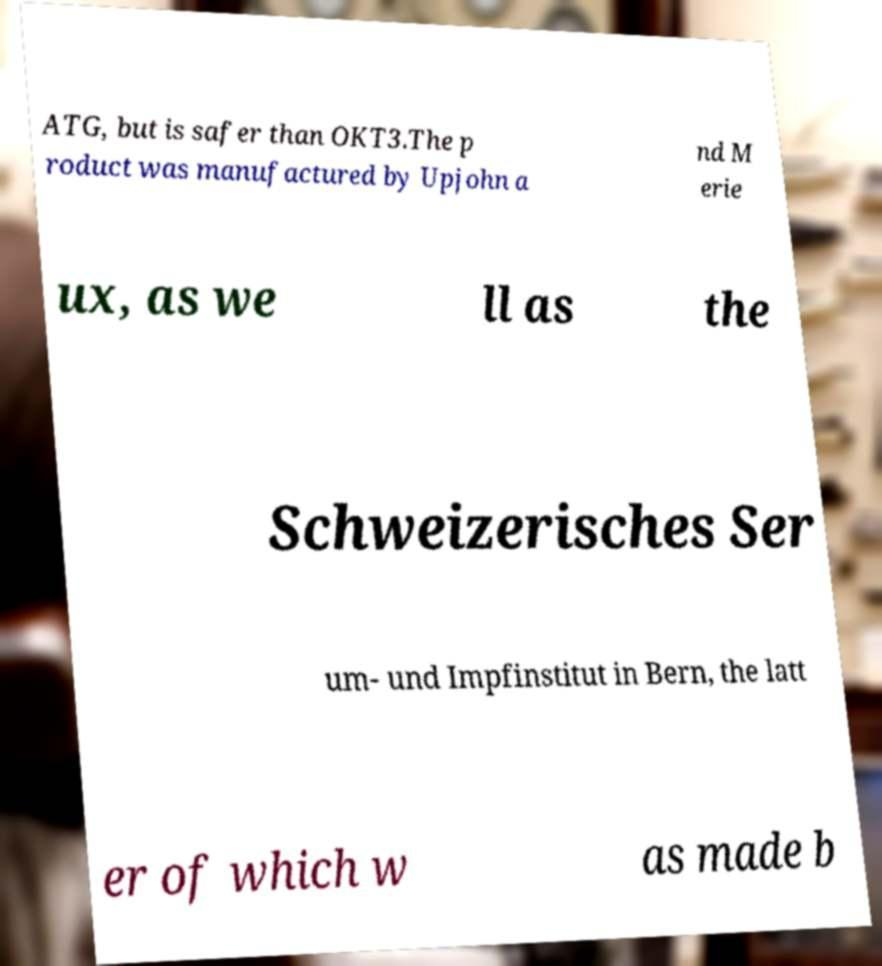Can you read and provide the text displayed in the image?This photo seems to have some interesting text. Can you extract and type it out for me? ATG, but is safer than OKT3.The p roduct was manufactured by Upjohn a nd M erie ux, as we ll as the Schweizerisches Ser um- und Impfinstitut in Bern, the latt er of which w as made b 